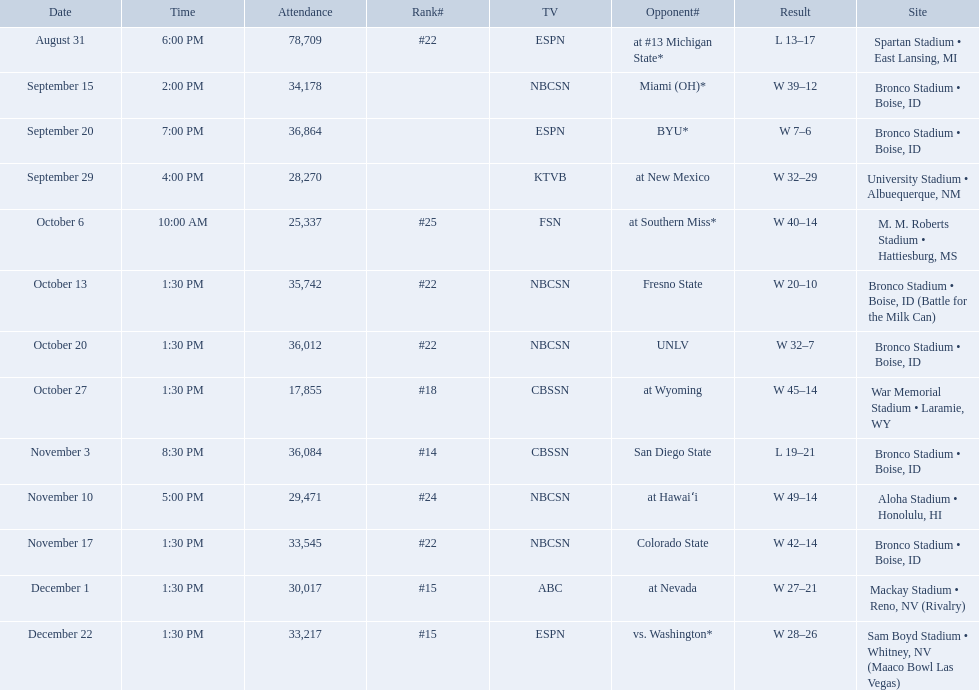What are the opponent teams of the 2012 boise state broncos football team? At #13 michigan state*, miami (oh)*, byu*, at new mexico, at southern miss*, fresno state, unlv, at wyoming, san diego state, at hawaiʻi, colorado state, at nevada, vs. washington*. How has the highest rank of these opponents? San Diego State. Who were all of the opponents? At #13 michigan state*, miami (oh)*, byu*, at new mexico, at southern miss*, fresno state, unlv, at wyoming, san diego state, at hawaiʻi, colorado state, at nevada, vs. washington*. Parse the table in full. {'header': ['Date', 'Time', 'Attendance', 'Rank#', 'TV', 'Opponent#', 'Result', 'Site'], 'rows': [['August 31', '6:00 PM', '78,709', '#22', 'ESPN', 'at\xa0#13\xa0Michigan State*', 'L\xa013–17', 'Spartan Stadium • East Lansing, MI'], ['September 15', '2:00 PM', '34,178', '', 'NBCSN', 'Miami (OH)*', 'W\xa039–12', 'Bronco Stadium • Boise, ID'], ['September 20', '7:00 PM', '36,864', '', 'ESPN', 'BYU*', 'W\xa07–6', 'Bronco Stadium • Boise, ID'], ['September 29', '4:00 PM', '28,270', '', 'KTVB', 'at\xa0New Mexico', 'W\xa032–29', 'University Stadium • Albuequerque, NM'], ['October 6', '10:00 AM', '25,337', '#25', 'FSN', 'at\xa0Southern Miss*', 'W\xa040–14', 'M. M. Roberts Stadium • Hattiesburg, MS'], ['October 13', '1:30 PM', '35,742', '#22', 'NBCSN', 'Fresno State', 'W\xa020–10', 'Bronco Stadium • Boise, ID (Battle for the Milk Can)'], ['October 20', '1:30 PM', '36,012', '#22', 'NBCSN', 'UNLV', 'W\xa032–7', 'Bronco Stadium • Boise, ID'], ['October 27', '1:30 PM', '17,855', '#18', 'CBSSN', 'at\xa0Wyoming', 'W\xa045–14', 'War Memorial Stadium • Laramie, WY'], ['November 3', '8:30 PM', '36,084', '#14', 'CBSSN', 'San Diego State', 'L\xa019–21', 'Bronco Stadium • Boise, ID'], ['November 10', '5:00 PM', '29,471', '#24', 'NBCSN', 'at\xa0Hawaiʻi', 'W\xa049–14', 'Aloha Stadium • Honolulu, HI'], ['November 17', '1:30 PM', '33,545', '#22', 'NBCSN', 'Colorado State', 'W\xa042–14', 'Bronco Stadium • Boise, ID'], ['December 1', '1:30 PM', '30,017', '#15', 'ABC', 'at\xa0Nevada', 'W\xa027–21', 'Mackay Stadium • Reno, NV (Rivalry)'], ['December 22', '1:30 PM', '33,217', '#15', 'ESPN', 'vs.\xa0Washington*', 'W\xa028–26', 'Sam Boyd Stadium • Whitney, NV (Maaco Bowl Las Vegas)']]} Who did they face on november 3rd? San Diego State. What rank were they on november 3rd? #14. 